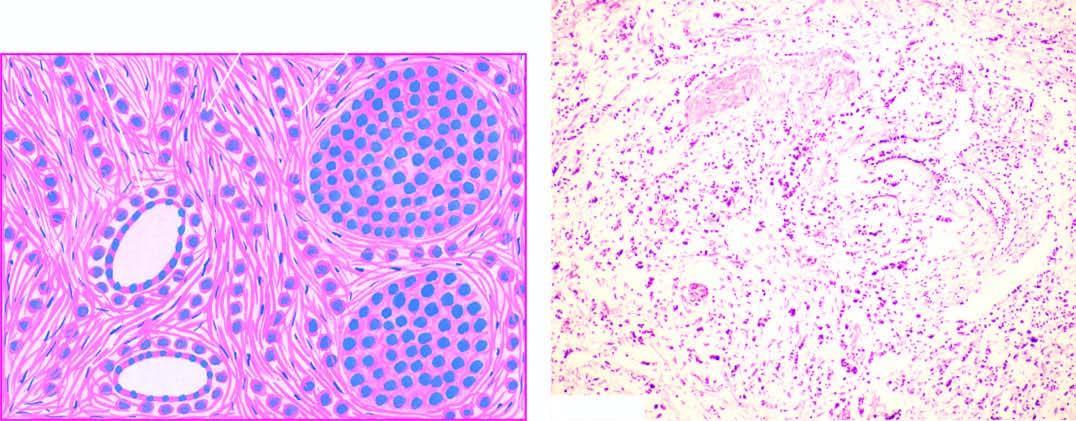what are characteristic histologic features?
Answer the question using a single word or phrase. One cell wide files of round regular tumour cells 